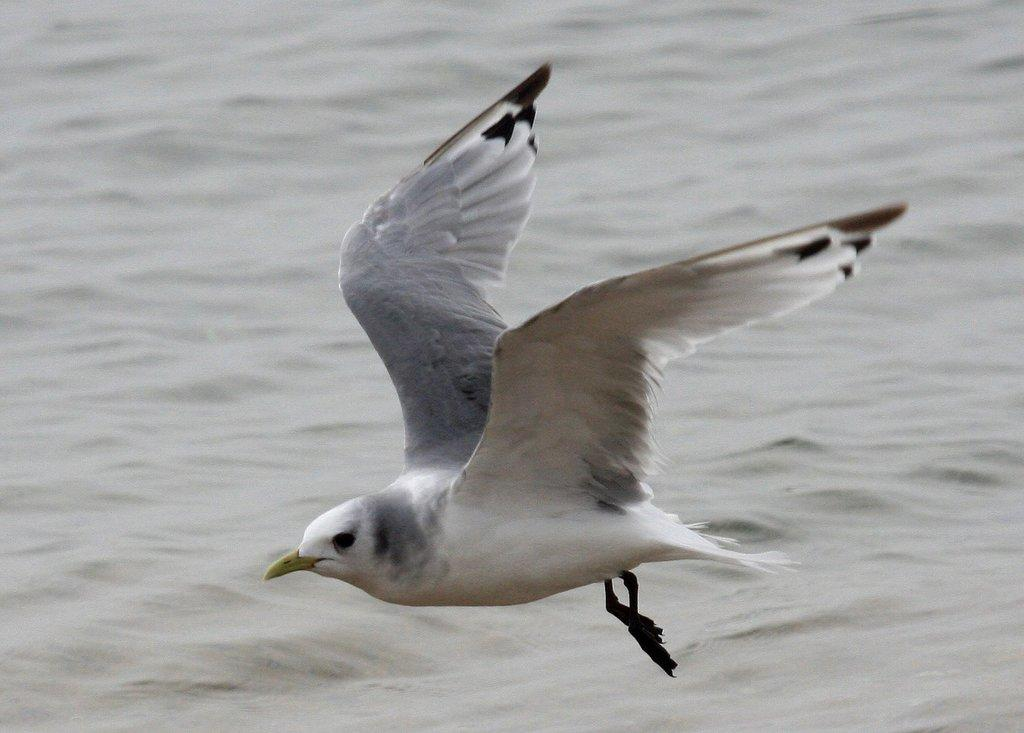What is the main subject of the image? There is a bird in the center of the image. Can you describe the bird's surroundings? There is water visible in the background of the image. What type of fuel is the bird using to fly in the image? The bird does not appear to be flying in the image, and there is no information about fuel. 